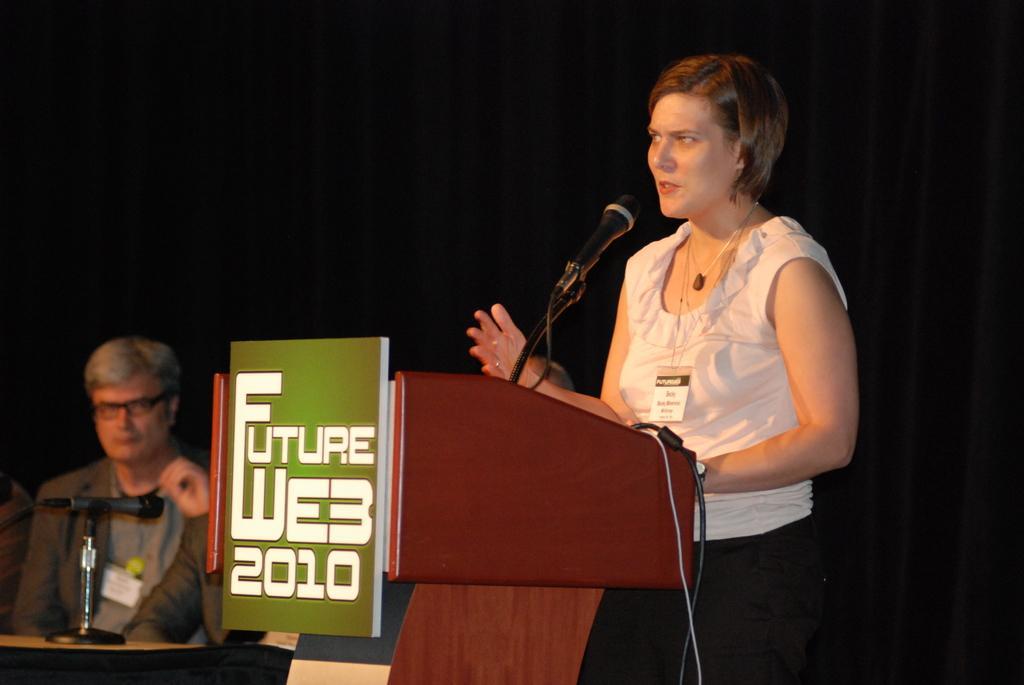In one or two sentences, can you explain what this image depicts? A women is standing, this is microphone, here two men are sitting, this is wooden structure, there is black color background. 